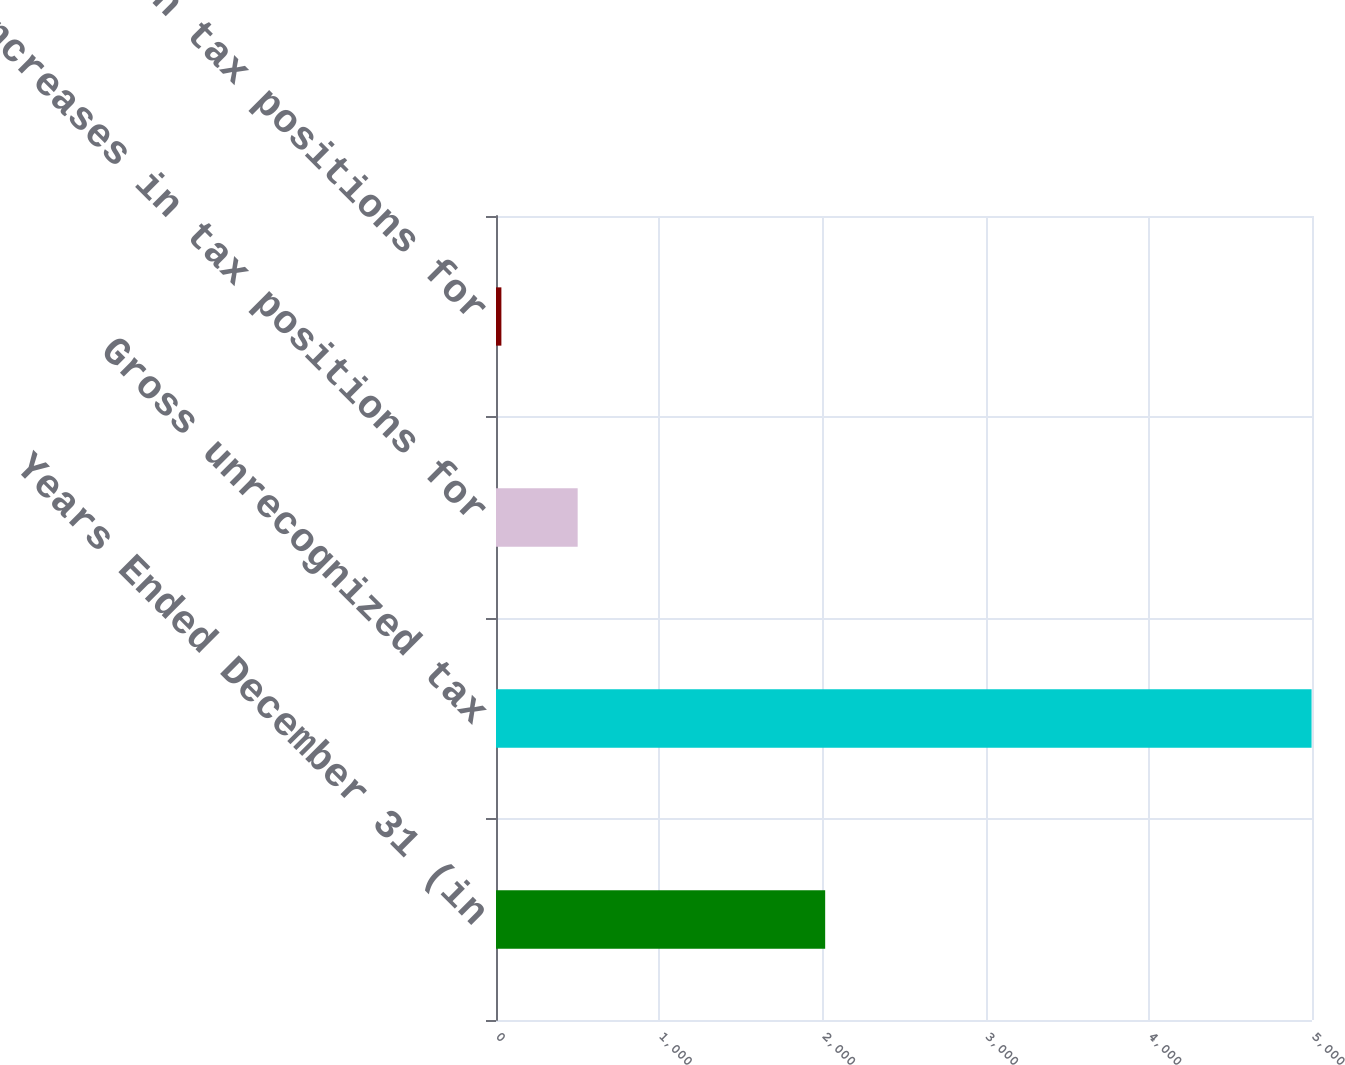Convert chart. <chart><loc_0><loc_0><loc_500><loc_500><bar_chart><fcel>Years Ended December 31 (in<fcel>Gross unrecognized tax<fcel>Increases in tax positions for<fcel>Decreases in tax positions for<nl><fcel>2017<fcel>4997.4<fcel>500.4<fcel>33<nl></chart> 